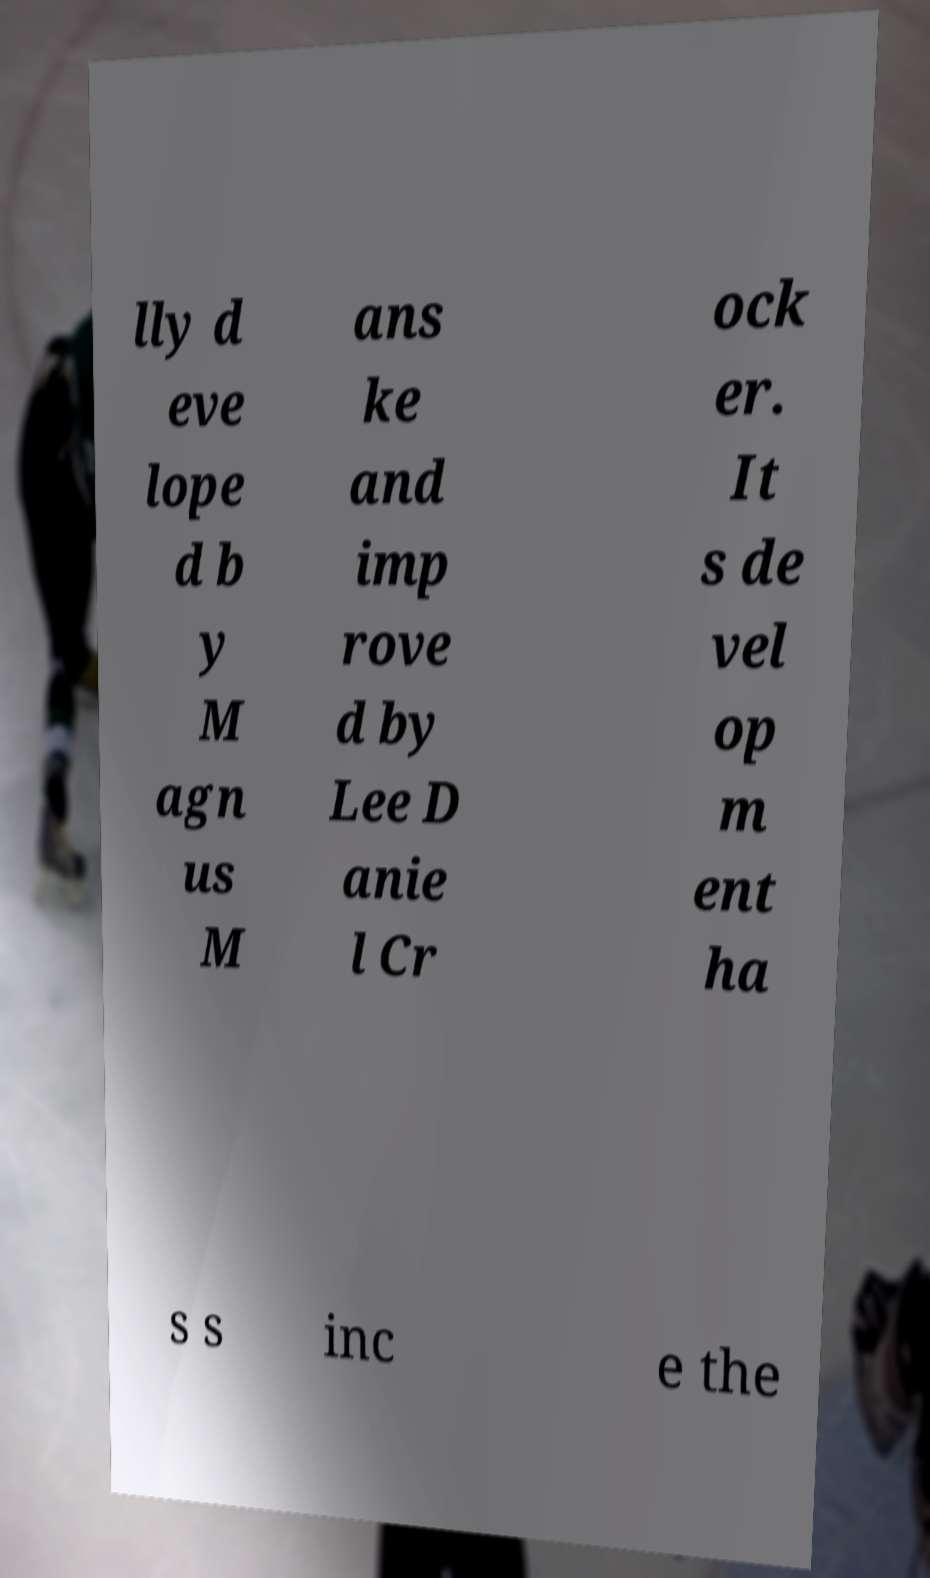Could you extract and type out the text from this image? lly d eve lope d b y M agn us M ans ke and imp rove d by Lee D anie l Cr ock er. It s de vel op m ent ha s s inc e the 